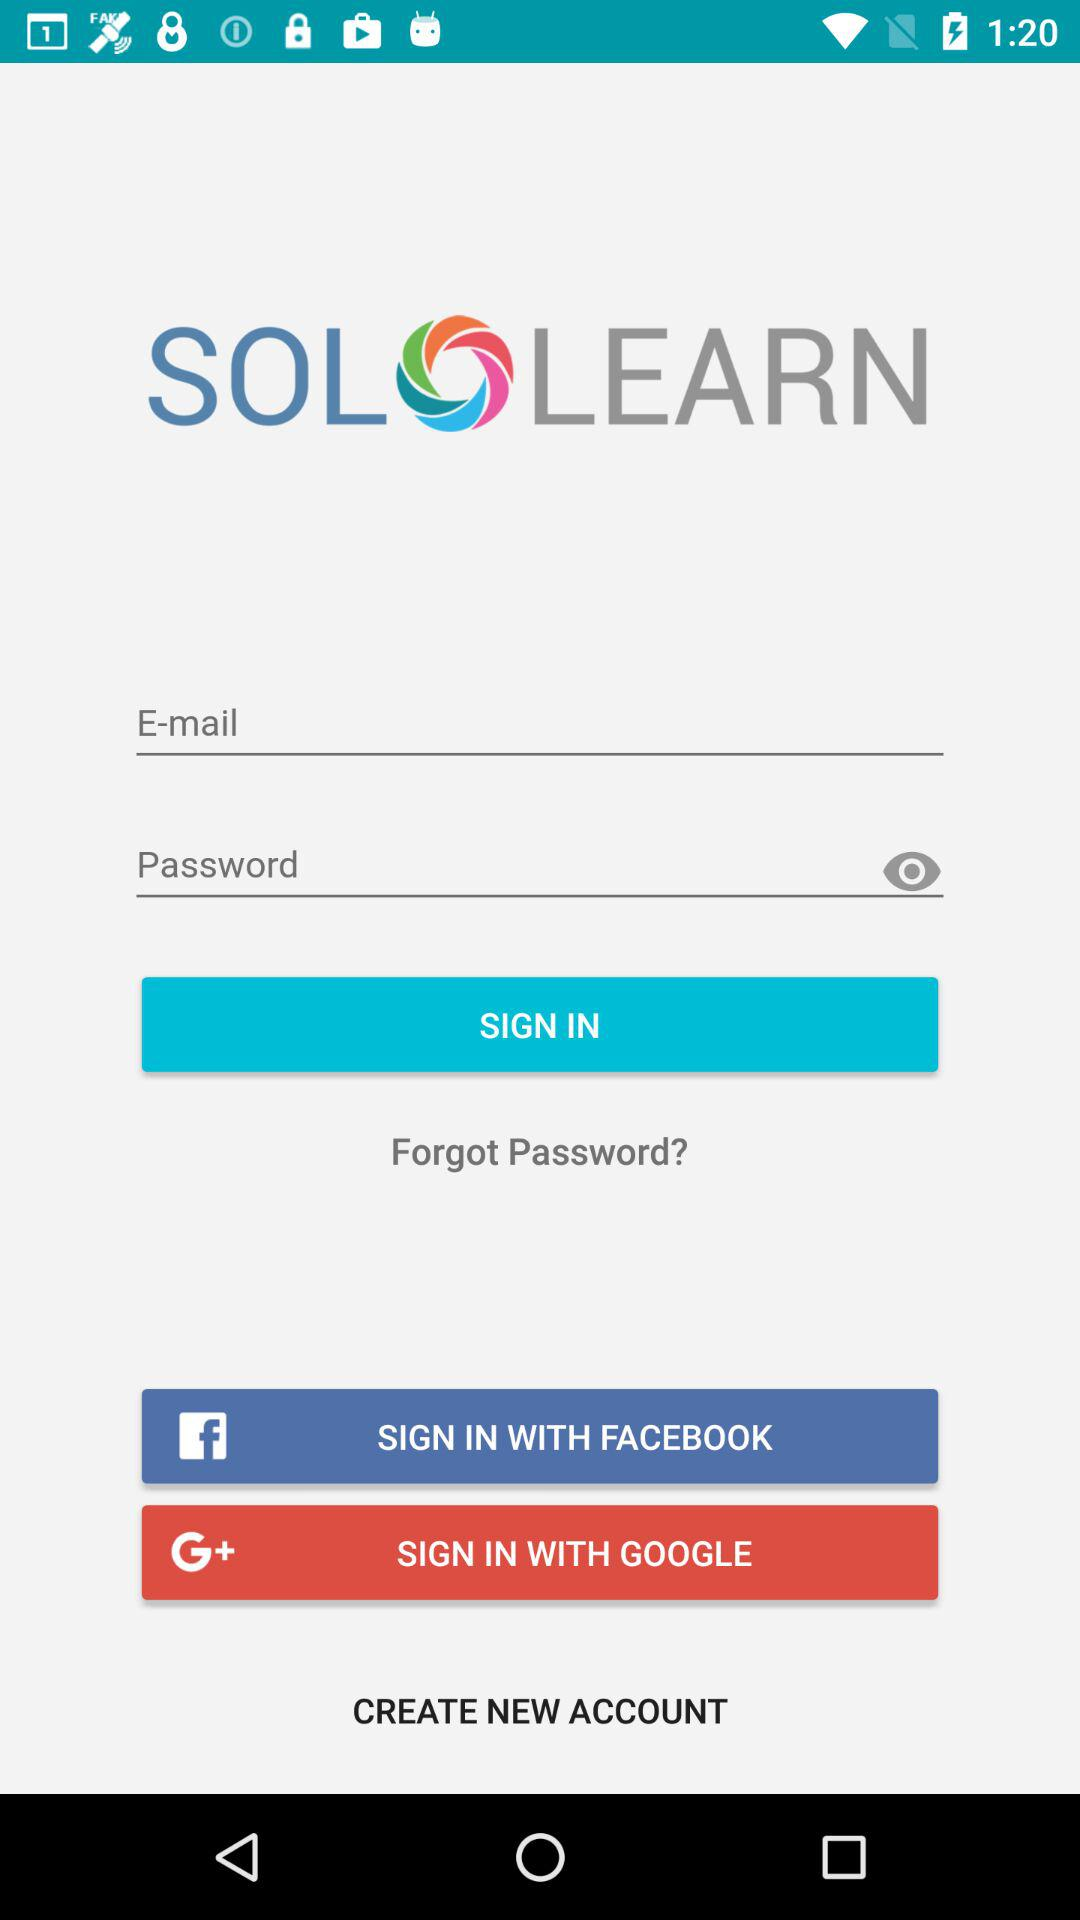How many inputs are there for the user to fill in?
Answer the question using a single word or phrase. 2 